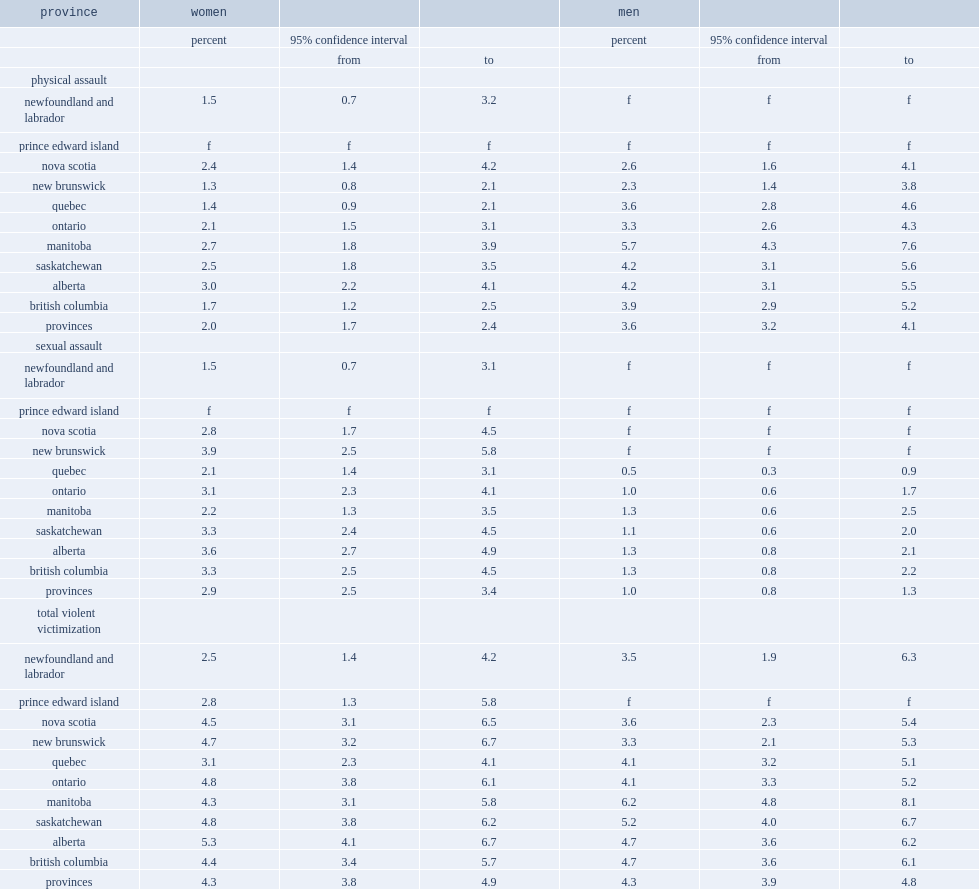What is the proportion of women in newfoundland and labrador in the past 12 months of 2018 had been violently victimized? 2.5. What is the proportion of women in quebec in the past 12 months of 2018 had been violently victimized? 3.1. What is the proportion of women overall in the past 12 months of 2018 had been violently victimized? 4.3. Compared with the proportion of women who had been violently victimized in newfoundland and labrador and the overall in the past 12 months of 2018, which one is much higher? Provinces. Compared with the proportion of women who had been violently victimized in quebec and the overall in the past 12 months of 2018, which one is much higher? Provinces. Compared with the proportion of men who had been violently victimized in manitoba and the overall in the past 12 months of 2018, which one is much higher? Men. What is the proportion of men in manitoba in the past 12 months of 2018 had been violently victimized? 6.2. What is the proportion of men overall in the past 12 months of 2018 had been violently victimized? 4.3. Which gender was more likely to have been sexually assaulted in the 12 months preceding the survey of 2018? Women. What is the percentage of women who have been sexually assaulted in the 12 months preceding the survey of 2018? 2.9. What is the percentage of men who have been sexually assaulted in the 12 months preceding the survey of 2018? 1.0. Compared with the proportion of women in newfoundland and labrador and women overall who have been sexually assaulted in the past 12 months of 2018, which is much higher? Provinces. Compared with the proportion of women in quebec and women overall who have been sexually assaulted in the past 12 months of 2018, which is much higher? Provinces. Compared with the proportion of men in quebec and men overall who have been sexually assaulted in the past 12 months of 2018, which is much higher? Provinces. What is the percentage of women in newfoundland and labrador have been sexually assaulted in the past 12 months of 2018? 1.5. What is the percentage of women in quebec have been sexually assaulted in the past 12 months of 2018? 2.1. What is the percentage of men in quebec have been sexually assaulted in the past 12 months of 2018? 0.5. 